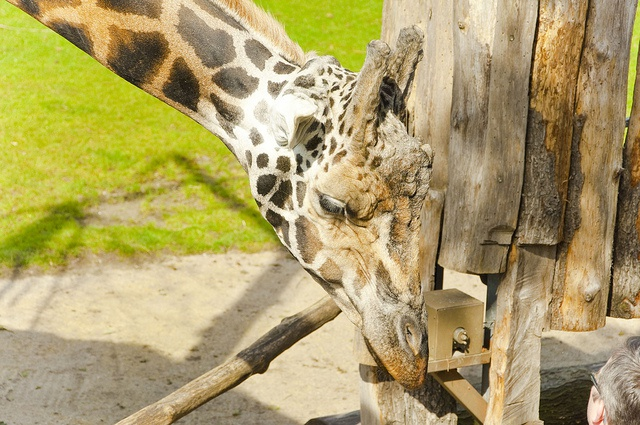Describe the objects in this image and their specific colors. I can see giraffe in khaki, beige, and tan tones and people in khaki, darkgray, tan, and gray tones in this image. 